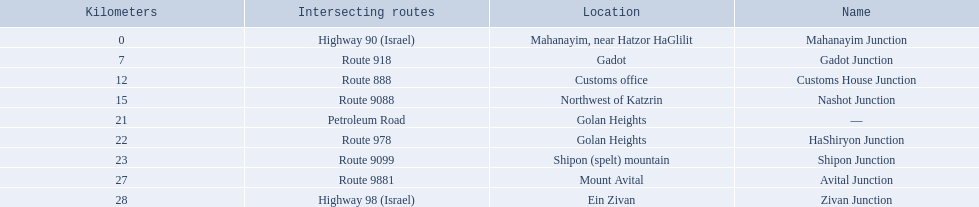Which intersecting routes are route 918 Route 918. What is the name? Gadot Junction. 